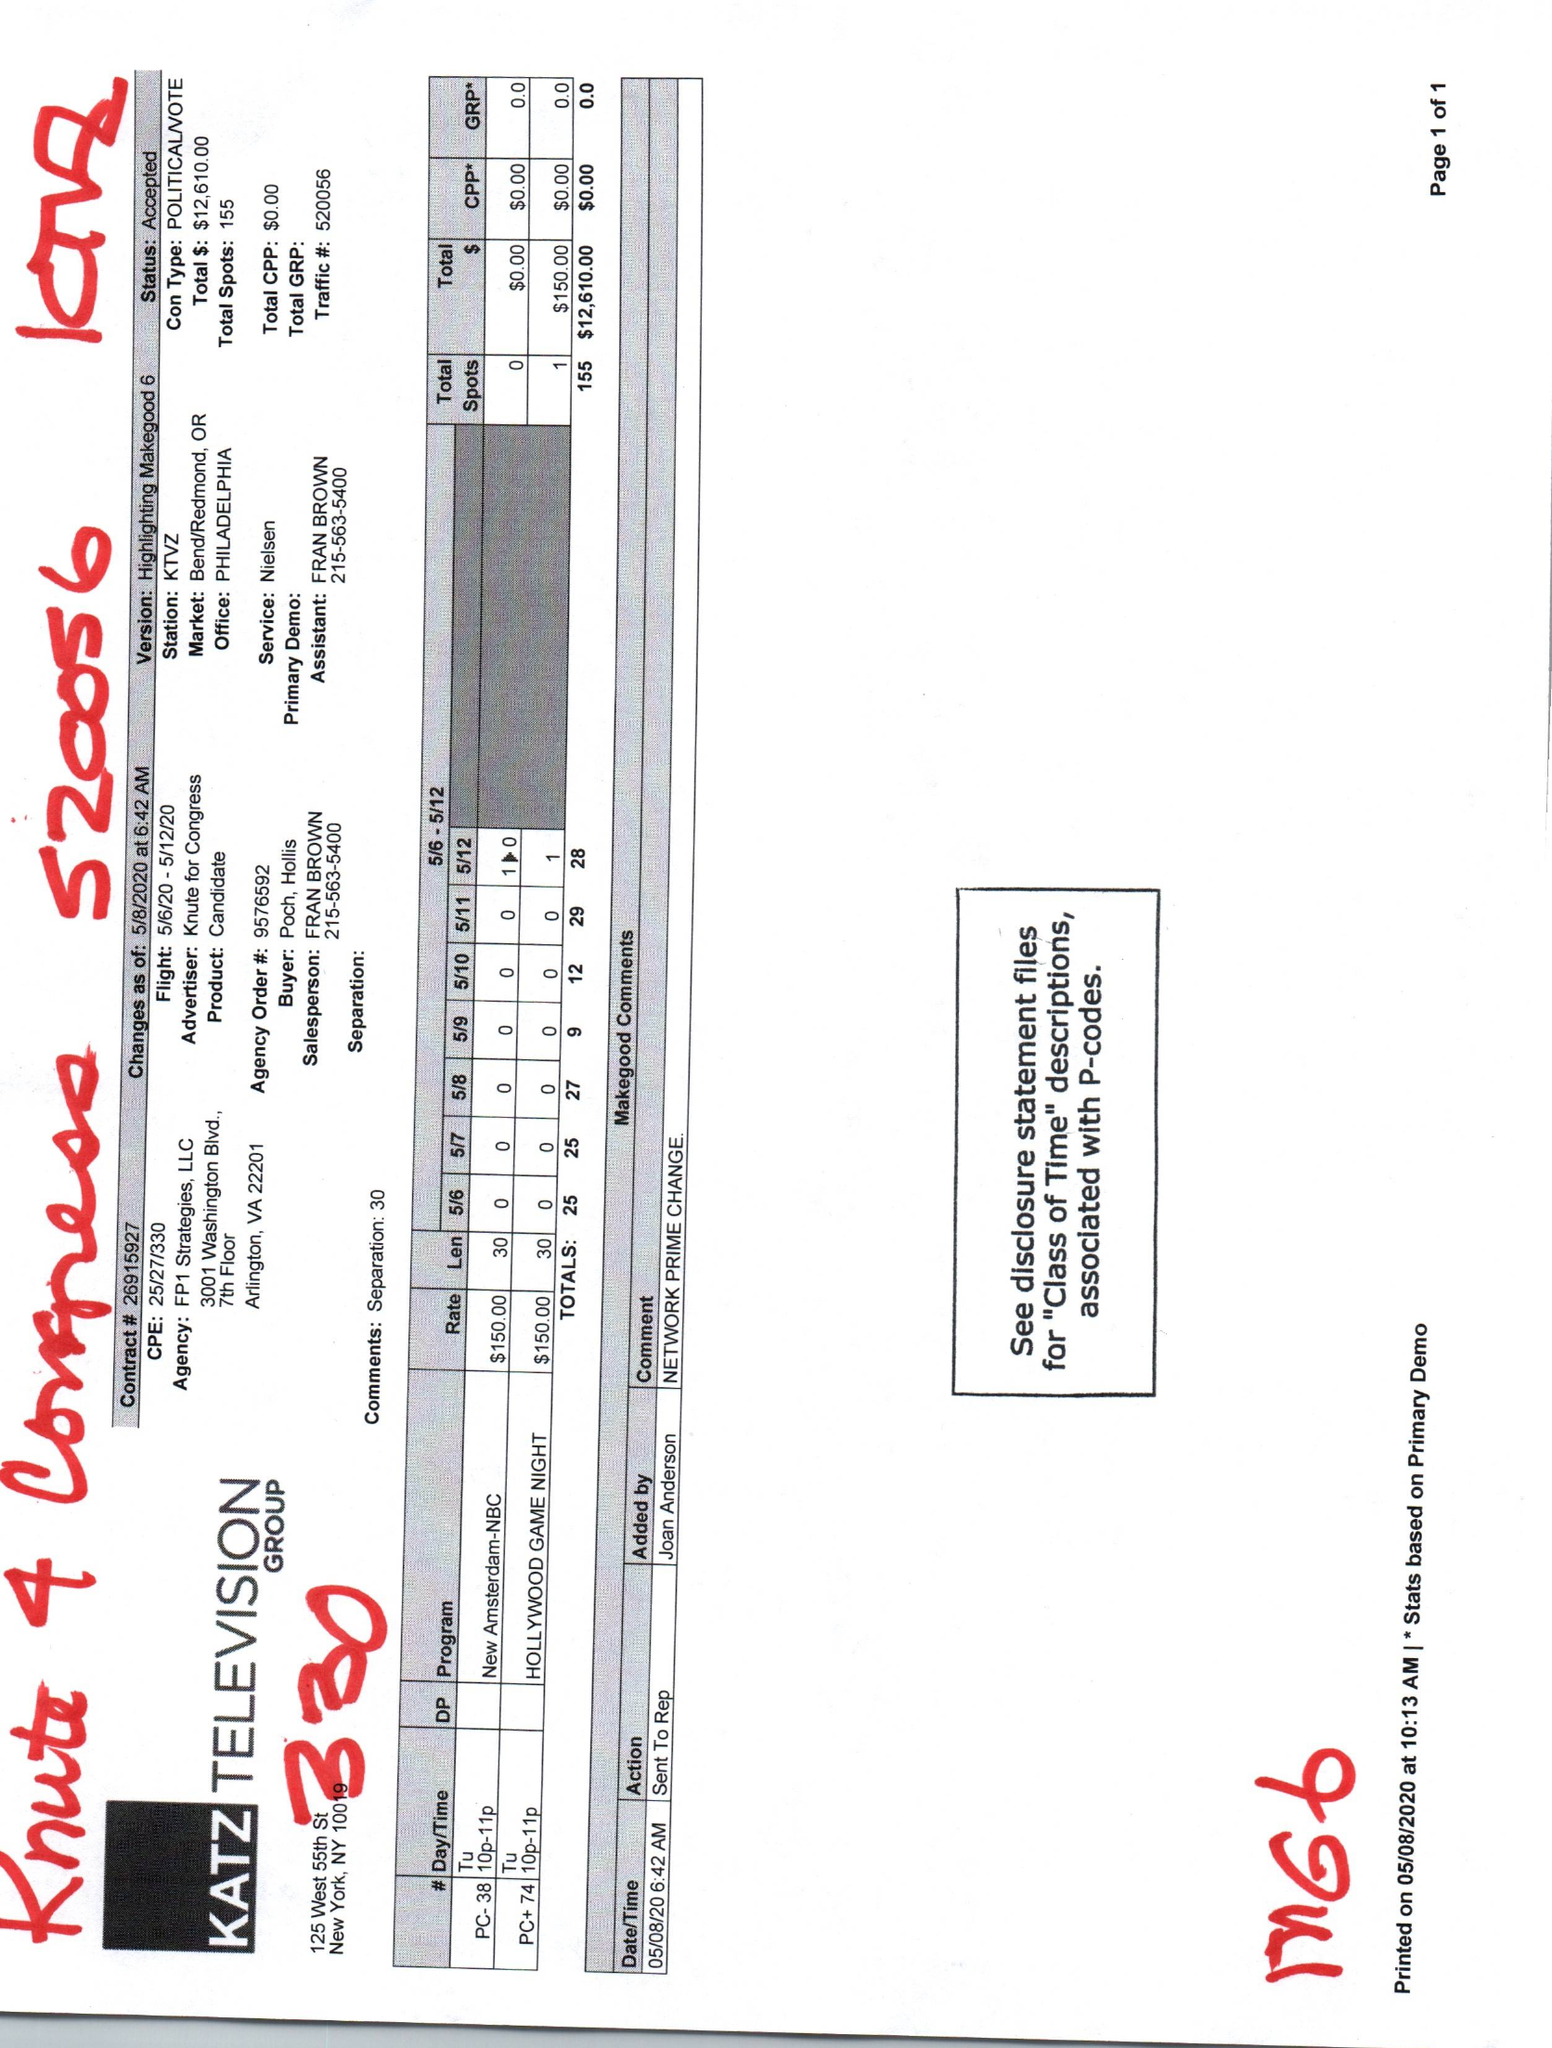What is the value for the gross_amount?
Answer the question using a single word or phrase. 12610.00 